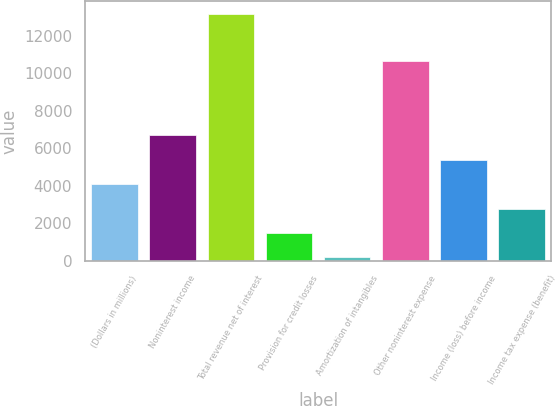Convert chart to OTSL. <chart><loc_0><loc_0><loc_500><loc_500><bar_chart><fcel>(Dollars in millions)<fcel>Noninterest income<fcel>Total revenue net of interest<fcel>Provision for credit losses<fcel>Amortization of intangibles<fcel>Other noninterest expense<fcel>Income (loss) before income<fcel>Income tax expense (benefit)<nl><fcel>4090.8<fcel>6688<fcel>13181<fcel>1493.6<fcel>195<fcel>10636<fcel>5389.4<fcel>2792.2<nl></chart> 